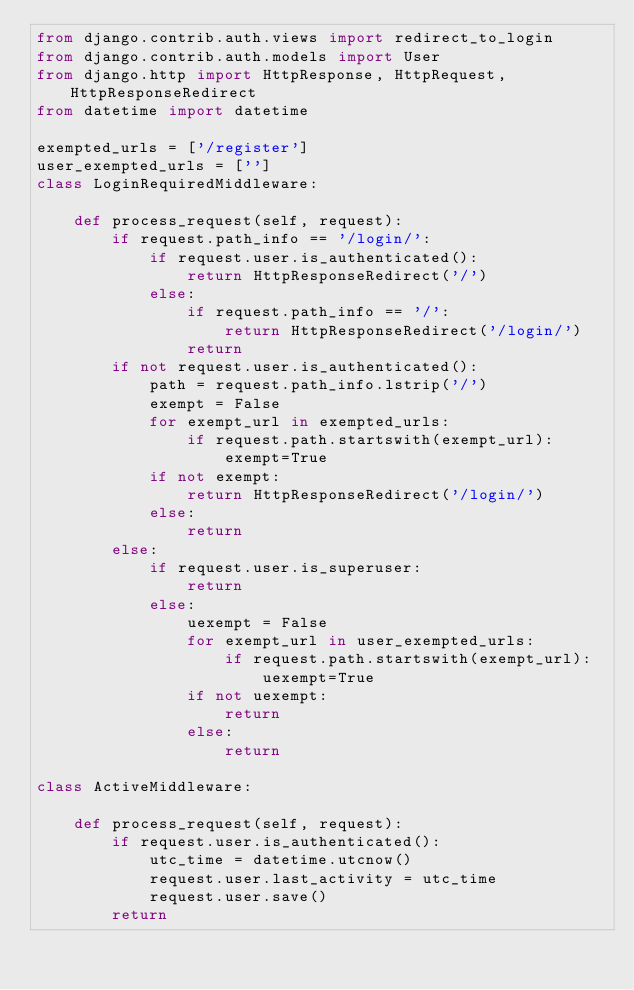<code> <loc_0><loc_0><loc_500><loc_500><_Python_>from django.contrib.auth.views import redirect_to_login
from django.contrib.auth.models import User
from django.http import HttpResponse, HttpRequest, HttpResponseRedirect
from datetime import datetime

exempted_urls = ['/register']
user_exempted_urls = ['']
class LoginRequiredMiddleware:
    
    def process_request(self, request):
        if request.path_info == '/login/':
            if request.user.is_authenticated():
                return HttpResponseRedirect('/')
            else:
                if request.path_info == '/':
                    return HttpResponseRedirect('/login/')
                return 
        if not request.user.is_authenticated():
            path = request.path_info.lstrip('/')
            exempt = False
            for exempt_url in exempted_urls:
                if request.path.startswith(exempt_url):
                    exempt=True
            if not exempt:
                return HttpResponseRedirect('/login/')
            else:
                return
        else:
            if request.user.is_superuser:
                return
            else:
                uexempt = False
                for exempt_url in user_exempted_urls:
                    if request.path.startswith(exempt_url):
                        uexempt=True
                if not uexempt:
                    return 
                else:
                    return 

class ActiveMiddleware:

    def process_request(self, request):
        if request.user.is_authenticated():
            utc_time = datetime.utcnow()
            request.user.last_activity = utc_time
            request.user.save()
        return
            
</code> 